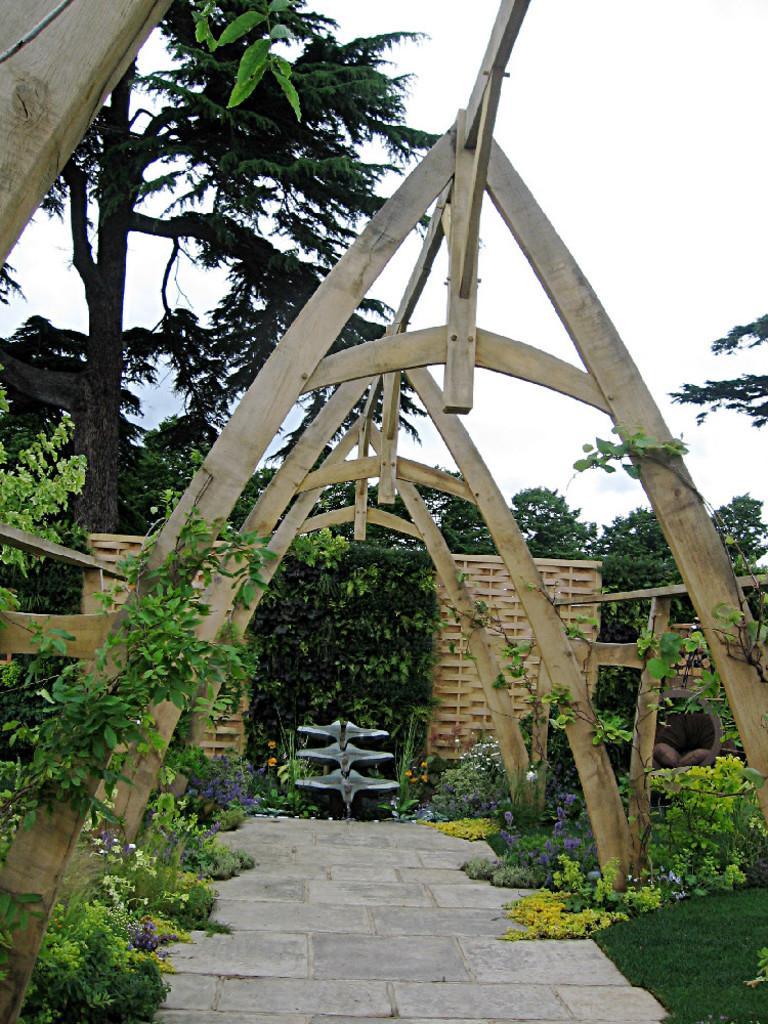In one or two sentences, can you explain what this image depicts? In this image, we can see an architecture. We can see some plants and trees, at the top we can see the sky. 